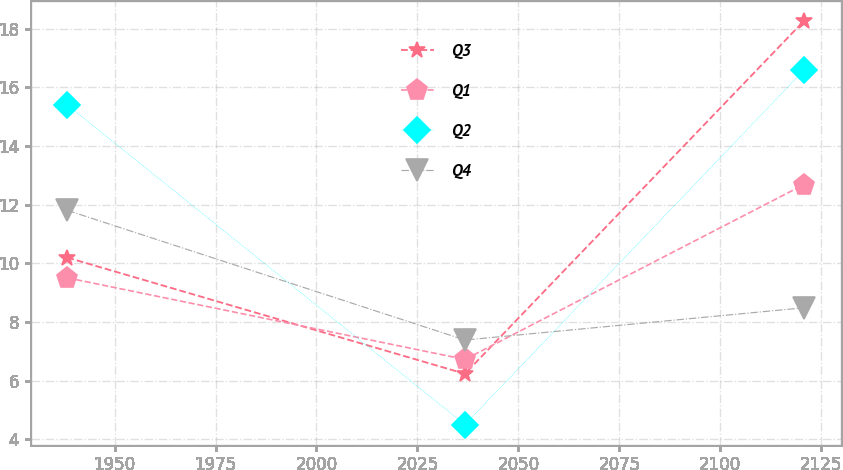Convert chart. <chart><loc_0><loc_0><loc_500><loc_500><line_chart><ecel><fcel>Q3<fcel>Q1<fcel>Q2<fcel>Q4<nl><fcel>1938.32<fcel>10.19<fcel>9.5<fcel>15.39<fcel>11.8<nl><fcel>2036.77<fcel>6.23<fcel>6.72<fcel>4.5<fcel>7.38<nl><fcel>2120.72<fcel>18.26<fcel>12.68<fcel>16.58<fcel>8.48<nl></chart> 